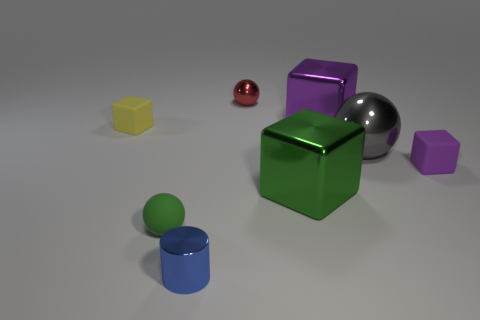Subtract all red balls. How many purple cubes are left? 2 Subtract all small balls. How many balls are left? 1 Add 2 brown cylinders. How many objects exist? 10 Subtract all yellow cubes. How many cubes are left? 3 Subtract 0 gray cylinders. How many objects are left? 8 Subtract all cylinders. How many objects are left? 7 Subtract 1 cylinders. How many cylinders are left? 0 Subtract all green cubes. Subtract all green balls. How many cubes are left? 3 Subtract all yellow rubber spheres. Subtract all small yellow cubes. How many objects are left? 7 Add 8 tiny green balls. How many tiny green balls are left? 9 